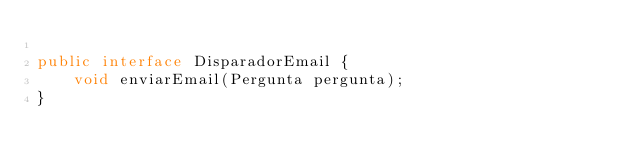<code> <loc_0><loc_0><loc_500><loc_500><_Java_>
public interface DisparadorEmail {
    void enviarEmail(Pergunta pergunta);
}
</code> 